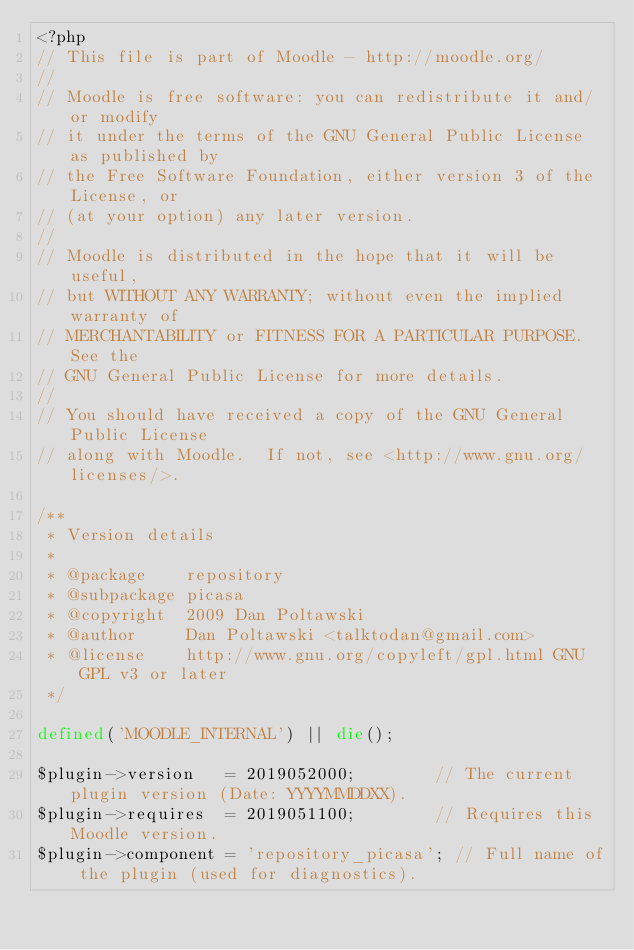Convert code to text. <code><loc_0><loc_0><loc_500><loc_500><_PHP_><?php
// This file is part of Moodle - http://moodle.org/
//
// Moodle is free software: you can redistribute it and/or modify
// it under the terms of the GNU General Public License as published by
// the Free Software Foundation, either version 3 of the License, or
// (at your option) any later version.
//
// Moodle is distributed in the hope that it will be useful,
// but WITHOUT ANY WARRANTY; without even the implied warranty of
// MERCHANTABILITY or FITNESS FOR A PARTICULAR PURPOSE.  See the
// GNU General Public License for more details.
//
// You should have received a copy of the GNU General Public License
// along with Moodle.  If not, see <http://www.gnu.org/licenses/>.

/**
 * Version details
 *
 * @package    repository
 * @subpackage picasa
 * @copyright  2009 Dan Poltawski
 * @author     Dan Poltawski <talktodan@gmail.com>
 * @license    http://www.gnu.org/copyleft/gpl.html GNU GPL v3 or later
 */

defined('MOODLE_INTERNAL') || die();

$plugin->version   = 2019052000;        // The current plugin version (Date: YYYYMMDDXX).
$plugin->requires  = 2019051100;        // Requires this Moodle version.
$plugin->component = 'repository_picasa'; // Full name of the plugin (used for diagnostics).
</code> 